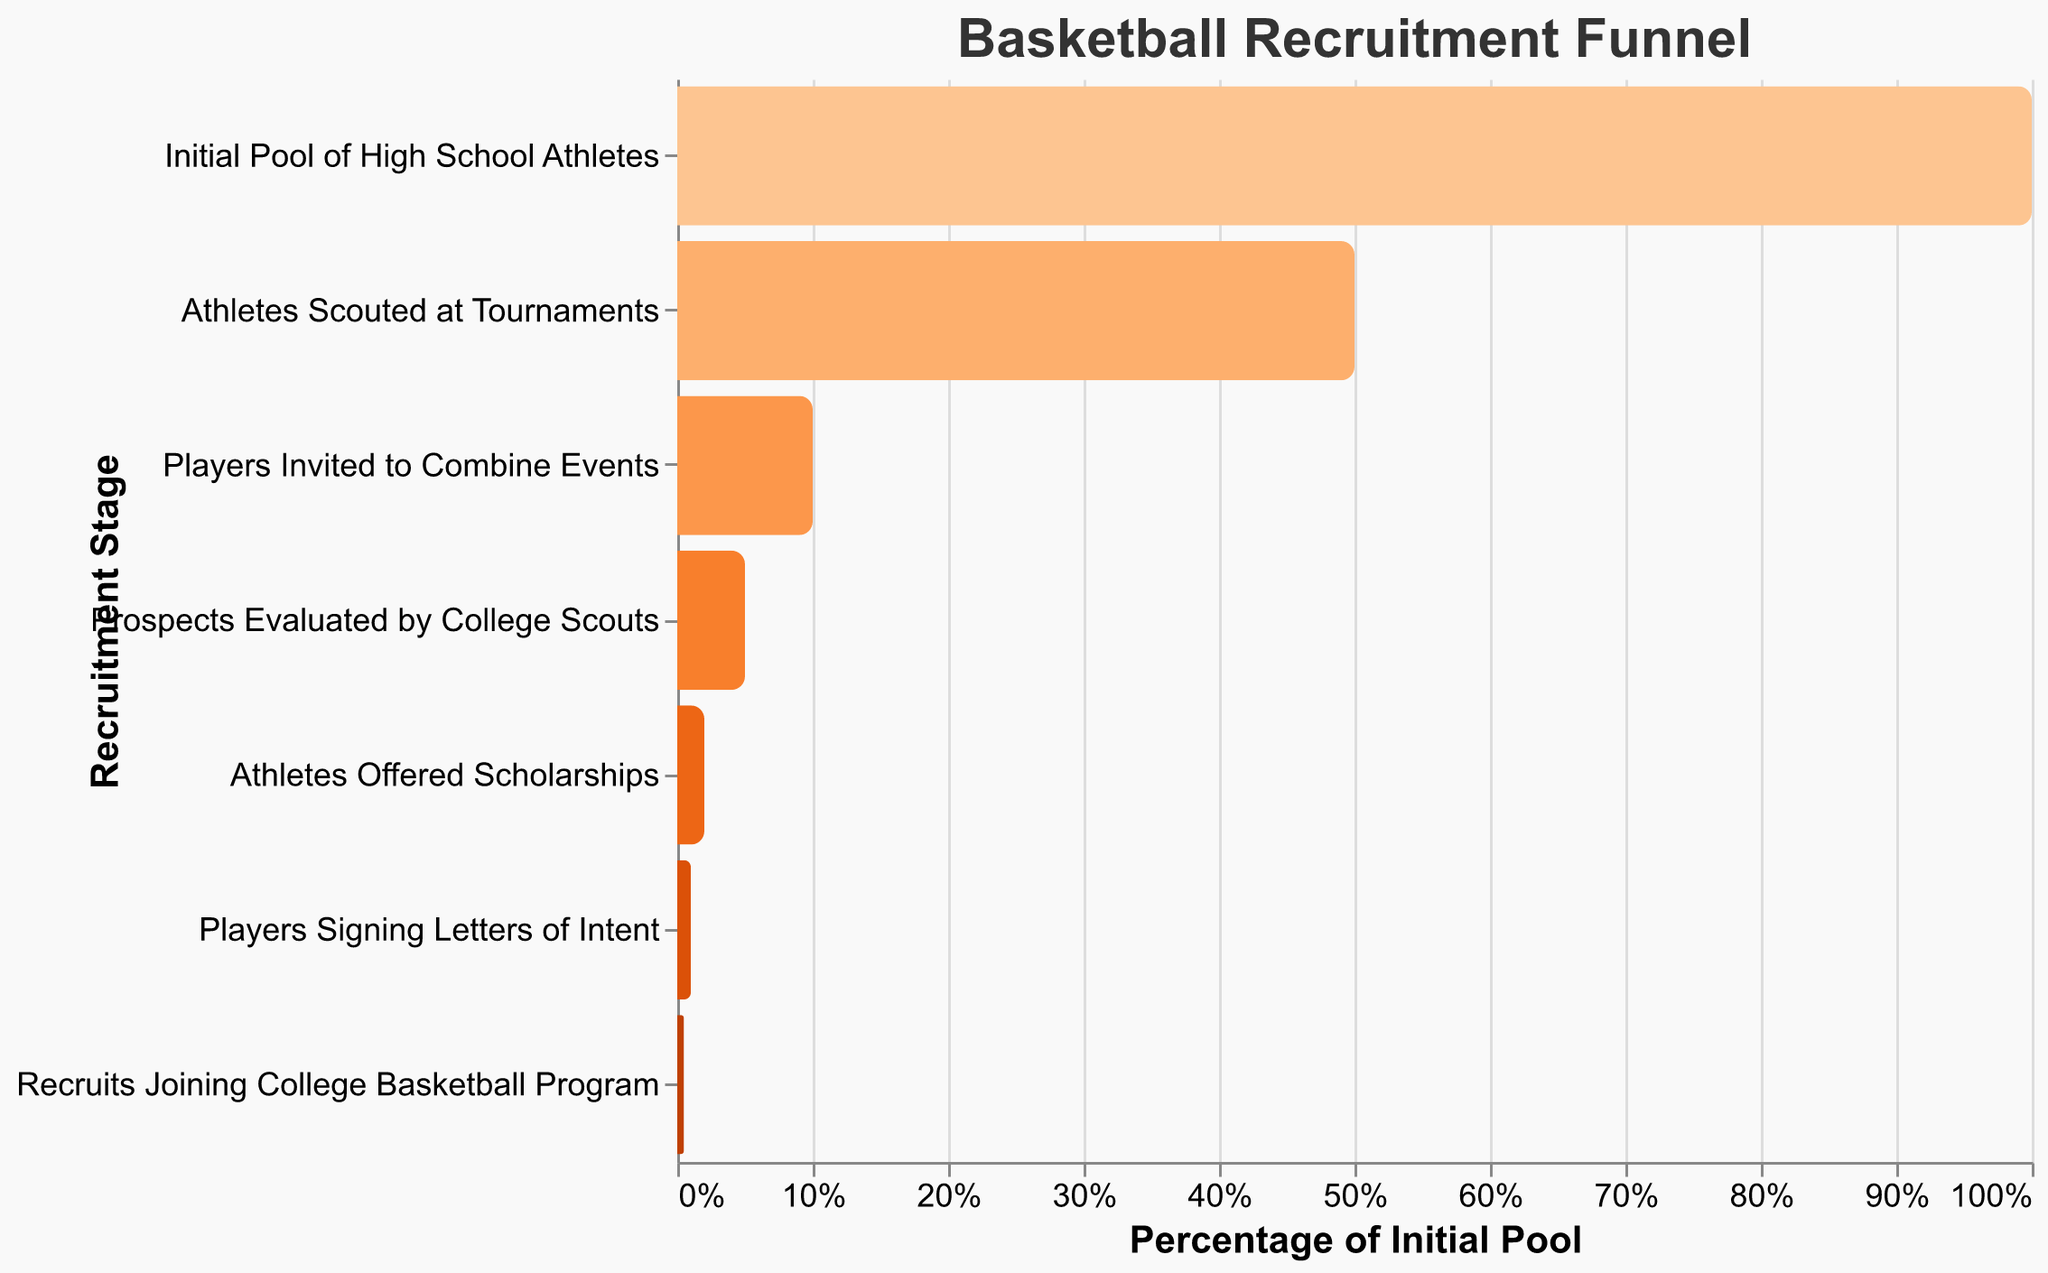What is the title of the chart? The title is displayed at the top of the chart and provides an overview of what the chart represents. In this case, it indicates the chart is about the recruitment funnel for basketball players.
Answer: Basketball Recruitment Funnel How many stages are there in the recruitment funnel? The stages can be counted directly from the chart where each horizontal bar represents a stage in the funnel.
Answer: Seven At which stage do athletes get invited to combine events, and how many are invited? By looking at the labels, you can identify the stage titled "Players Invited to Combine Events" and check the number of recruits listed for that stage.
Answer: 1,000 What percentage of the initial pool of high school athletes make it to the stage where they sign letters of intent? The figure includes a bar that represents the "Players Signing Letters of Intent" stage. This percentage is derived as the "Players Signing Letters of Intent" divided by the "Initial Pool of High School Athletes," represented as a percentage.
Answer: 1% What is the difference in the number of recruits between the "Athletes Scouted at Tournaments" stage and the "Prospects Evaluated by College Scouts" stage? Subtract the number of recruits at the "Prospects Evaluated by College Scouts" stage from those at the "Athletes Scouted at Tournaments" stage: 5,000 - 500 = 4,500.
Answer: 4,500 Which stage sees the greatest drop-off in the number of recruits? By comparing the number of recruits at each stage, you can identify the stages with the most significant declines. The drop from "Athletes Scouted at Tournaments" (5,000) to "Players Invited to Combine Events" (1,000) is the largest.
Answer: Athletes Scouted at Tournaments to Players Invited to Combine Events What percentage of the recruits evaluated by college scouts receive scholarship offers? The percentage is calculated by dividing the number of "Athletes Offered Scholarships" by the number of "Prospects Evaluated by College Scouts" and multiplying by 100: (200 / 500) * 100.
Answer: 40% How many recruits join the college basketball program, and what percentage is this of the initial pool? The recruit number for the final stage is shown in the chart as "Recruits Joining College Basketball Program." To find the percentage, divide this number by the initial pool and multiply by 100: (50 / 10,000) * 100.
Answer: 0.5% What is the median stage in terms of the number of recruits, and what is its value? Order the stages by the number of recruits: [50, 100, 200, 500, 1,000, 5,000, 10,000]. The median value is the fourth value in this sequence.
Answer: Prospects Evaluated by College Scouts, 500 